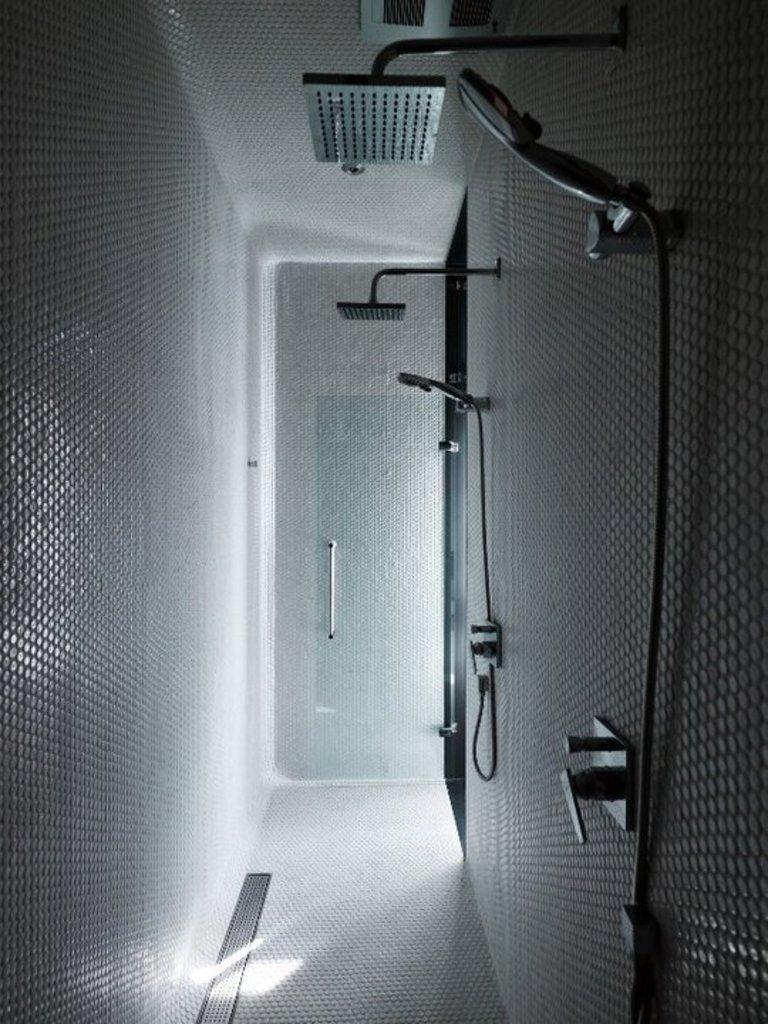Can you describe this image briefly? This picture describes about washroom, in this we can find few showers and a glass door. 